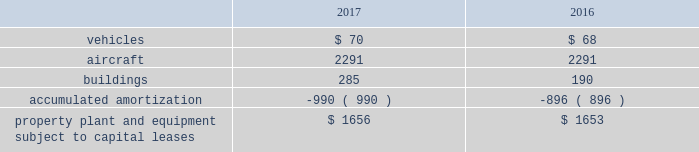United parcel service , inc .
And subsidiaries notes to consolidated financial statements floating-rate senior notes the floating-rate senior notes with principal amounts totaling $ 1.043 billion , bear interest at either one or three-month libor , less a spread ranging from 30 to 45 basis points .
The average interest rate for 2017 and 2016 was 0.74% ( 0.74 % ) and 0.21% ( 0.21 % ) , respectively .
These notes are callable at various times after 30 years at a stated percentage of par value , and putable by the note holders at various times after one year at a stated percentage of par value .
The notes have maturities ranging from 2049 through 2067 .
We classified the floating-rate senior notes that are putable by the note holder as a long-term liability , due to our intent and ability to refinance the debt if the put option is exercised by the note holder .
In march and november 2017 , we issued floating-rate senior notes in the principal amounts of $ 147 and $ 64 million , respectively , which are included in the $ 1.043 billion floating-rate senior notes described above .
These notes will bear interest at three-month libor less 30 and 35 basis points , respectively and mature in 2067 .
The remaining three floating-rate senior notes in the principal amounts of $ 350 , $ 400 and $ 500 million , bear interest at three-month libor , plus a spread ranging from 15 to 45 basis points .
The average interest rate for 2017 and 2016 was 0.50% ( 0.50 % ) and 0.0% ( 0.0 % ) , respectively .
These notes are not callable .
The notes have maturities ranging from 2021 through 2023 .
We classified the floating-rate senior notes that are putable by the note holder as a long-term liability , due to our intent and ability to refinance the debt if the put option is exercised by the note holder .
Capital lease obligations we have certain property , plant and equipment subject to capital leases .
Some of the obligations associated with these capital leases have been legally defeased .
The recorded value of our property , plant and equipment subject to capital leases is as follows as of december 31 ( in millions ) : .
These capital lease obligations have principal payments due at various dates from 2018 through 3005 .
Facility notes and bonds we have entered into agreements with certain municipalities to finance the construction of , or improvements to , facilities that support our u.s .
Domestic package and supply chain & freight operations in the united states .
These facilities are located around airport properties in louisville , kentucky ; dallas , texas ; and philadelphia , pennsylvania .
Under these arrangements , we enter into a lease or loan agreement that covers the debt service obligations on the bonds issued by the municipalities , as follows : 2022 bonds with a principal balance of $ 149 million issued by the louisville regional airport authority associated with our worldport facility in louisville , kentucky .
The bonds , which are due in january 2029 , bear interest at a variable rate , and the average interest rates for 2017 and 2016 were 0.83% ( 0.83 % ) and 0.37% ( 0.37 % ) , respectively .
2022 bonds with a principal balance of $ 42 million and due in november 2036 issued by the louisville regional airport authority associated with our air freight facility in louisville , kentucky .
The bonds bear interest at a variable rate , and the average interest rates for 2017 and 2016 were 0.80% ( 0.80 % ) and 0.36% ( 0.36 % ) , respectively .
2022 bonds with a principal balance of $ 29 million issued by the dallas / fort worth international airport facility improvement corporation associated with our dallas , texas airport facilities .
The bonds are due in may 2032 and bear interest at a variable rate , however the variable cash flows on the obligation have been swapped to a fixed 5.11% ( 5.11 % ) .
2022 in september 2015 , we entered into an agreement with the delaware county , pennsylvania industrial development authority , associated with our philadelphia , pennsylvania airport facilities , for bonds issued with a principal balance of $ 100 million .
These bonds , which are due september 2045 , bear interest at a variable rate .
The average interest rate for 2017 and 2016 was 0.78% ( 0.78 % ) and 0.40% ( 0.40 % ) , respectively. .
What was the change in millions of buildings from 2016 to 2017? 
Computations: (285 - 190)
Answer: 95.0. 